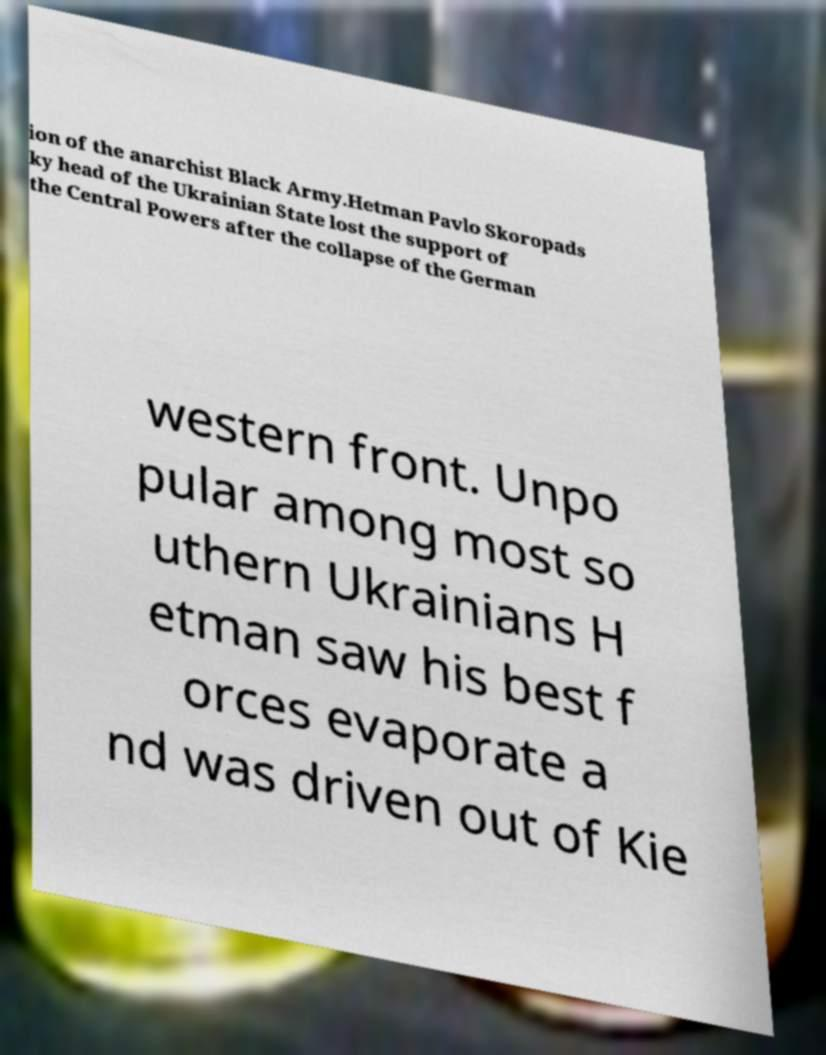Could you assist in decoding the text presented in this image and type it out clearly? ion of the anarchist Black Army.Hetman Pavlo Skoropads ky head of the Ukrainian State lost the support of the Central Powers after the collapse of the German western front. Unpo pular among most so uthern Ukrainians H etman saw his best f orces evaporate a nd was driven out of Kie 